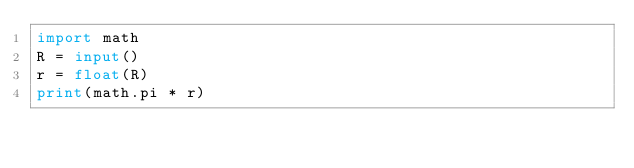<code> <loc_0><loc_0><loc_500><loc_500><_Python_>import math
R = input()
r = float(R)
print(math.pi * r)</code> 